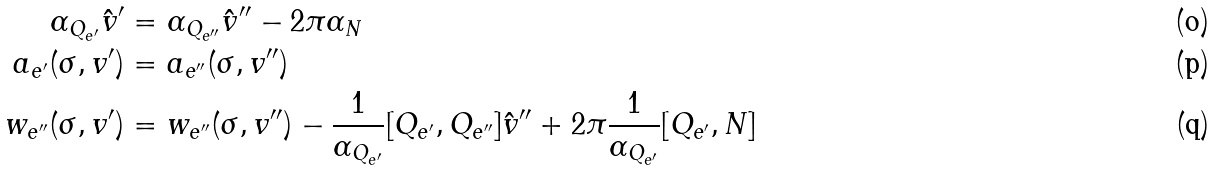<formula> <loc_0><loc_0><loc_500><loc_500>\alpha _ { Q _ { e ^ { \prime } } } \hat { v } ^ { \prime } & = \alpha _ { Q _ { e ^ { \prime \prime } } } \hat { v } ^ { \prime \prime } - 2 \pi \alpha _ { N } \\ a _ { e ^ { \prime } } ( \sigma , v ^ { \prime } ) & = a _ { e ^ { \prime \prime } } ( \sigma , v ^ { \prime \prime } ) \\ w _ { e ^ { \prime \prime } } ( \sigma , v ^ { \prime } ) & = w _ { e ^ { \prime \prime } } ( \sigma , v ^ { \prime \prime } ) - \frac { 1 } { \alpha _ { Q _ { e ^ { \prime } } } } [ Q _ { e ^ { \prime } } , Q _ { e ^ { \prime \prime } } ] \hat { v } ^ { \prime \prime } + 2 \pi \frac { 1 } { \alpha _ { Q _ { e ^ { \prime } } } } [ Q _ { e ^ { \prime } } , N ]</formula> 